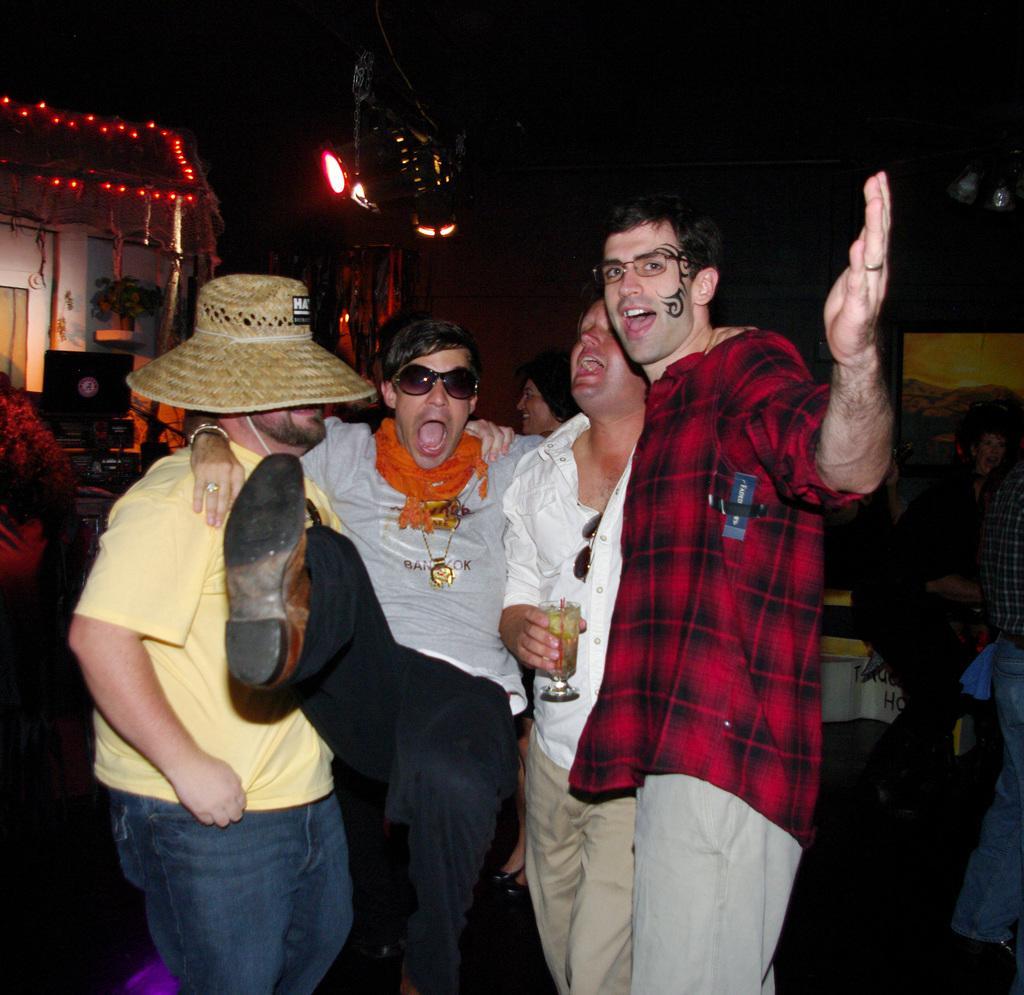In one or two sentences, can you explain what this image depicts? In this image we can see some persons, glass and other objects. In the background of the image there are some persons, lights, monitor and other objects. 